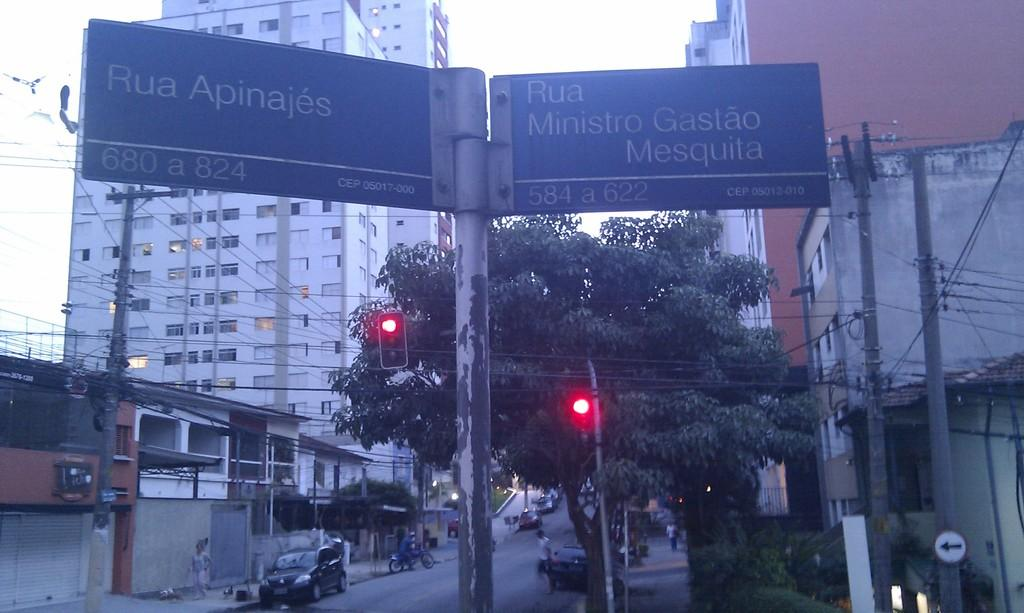<image>
Give a short and clear explanation of the subsequent image. a sign above the ground that says Ria on it 